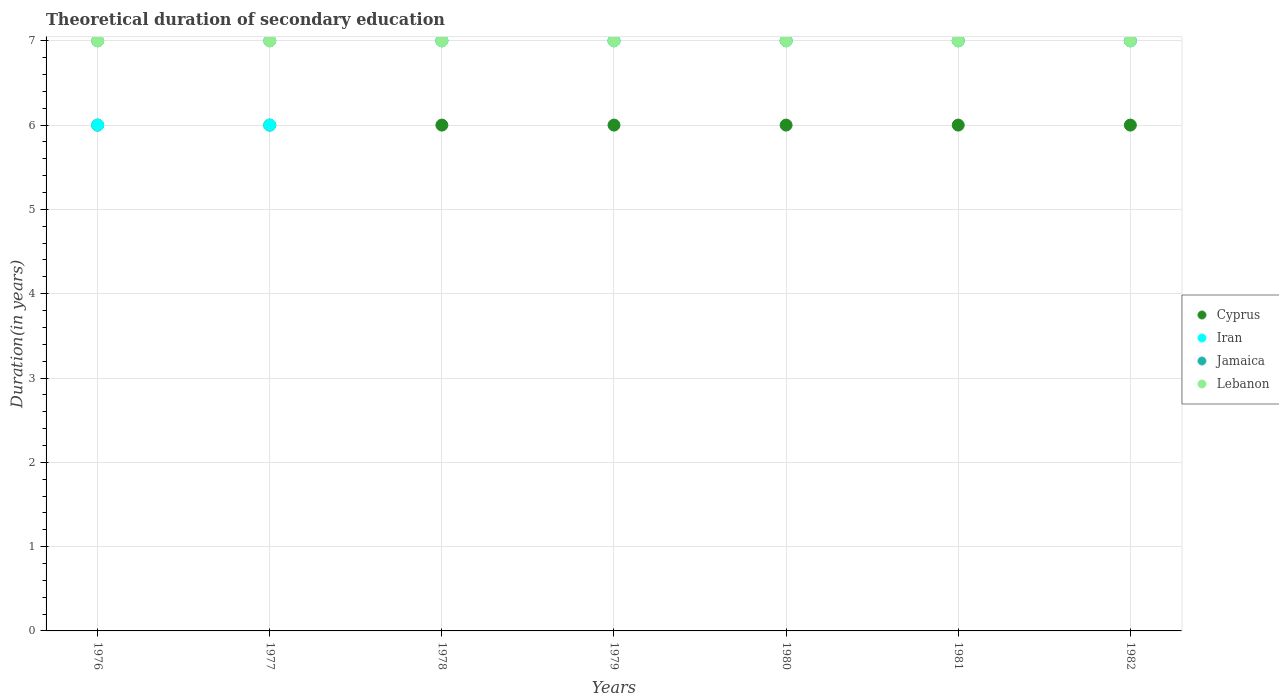How many different coloured dotlines are there?
Your answer should be very brief. 4. Is the number of dotlines equal to the number of legend labels?
Provide a short and direct response. Yes. What is the total theoretical duration of secondary education in Iran in 1978?
Offer a very short reply. 7. Across all years, what is the maximum total theoretical duration of secondary education in Cyprus?
Offer a very short reply. 6. Across all years, what is the minimum total theoretical duration of secondary education in Lebanon?
Your answer should be very brief. 7. In which year was the total theoretical duration of secondary education in Lebanon maximum?
Your response must be concise. 1976. In which year was the total theoretical duration of secondary education in Cyprus minimum?
Keep it short and to the point. 1976. What is the total total theoretical duration of secondary education in Cyprus in the graph?
Provide a succinct answer. 42. What is the difference between the total theoretical duration of secondary education in Jamaica in 1976 and that in 1981?
Your answer should be compact. 0. What is the difference between the total theoretical duration of secondary education in Iran in 1979 and the total theoretical duration of secondary education in Cyprus in 1978?
Offer a terse response. 1. What is the average total theoretical duration of secondary education in Iran per year?
Give a very brief answer. 6.71. In the year 1976, what is the difference between the total theoretical duration of secondary education in Lebanon and total theoretical duration of secondary education in Jamaica?
Provide a succinct answer. 0. In how many years, is the total theoretical duration of secondary education in Cyprus greater than 0.6000000000000001 years?
Provide a succinct answer. 7. What is the ratio of the total theoretical duration of secondary education in Jamaica in 1977 to that in 1978?
Offer a very short reply. 1. What is the difference between the highest and the lowest total theoretical duration of secondary education in Iran?
Your answer should be compact. 1. In how many years, is the total theoretical duration of secondary education in Cyprus greater than the average total theoretical duration of secondary education in Cyprus taken over all years?
Your answer should be compact. 0. Is the sum of the total theoretical duration of secondary education in Lebanon in 1976 and 1981 greater than the maximum total theoretical duration of secondary education in Cyprus across all years?
Your answer should be very brief. Yes. Is it the case that in every year, the sum of the total theoretical duration of secondary education in Lebanon and total theoretical duration of secondary education in Jamaica  is greater than the sum of total theoretical duration of secondary education in Cyprus and total theoretical duration of secondary education in Iran?
Your answer should be compact. No. Does the total theoretical duration of secondary education in Jamaica monotonically increase over the years?
Your answer should be very brief. No. How many dotlines are there?
Ensure brevity in your answer.  4. How many years are there in the graph?
Your answer should be compact. 7. Does the graph contain any zero values?
Offer a very short reply. No. Where does the legend appear in the graph?
Give a very brief answer. Center right. What is the title of the graph?
Make the answer very short. Theoretical duration of secondary education. What is the label or title of the X-axis?
Offer a very short reply. Years. What is the label or title of the Y-axis?
Offer a terse response. Duration(in years). What is the Duration(in years) of Iran in 1976?
Make the answer very short. 6. What is the Duration(in years) in Cyprus in 1977?
Your response must be concise. 6. What is the Duration(in years) in Iran in 1977?
Keep it short and to the point. 6. What is the Duration(in years) in Jamaica in 1977?
Offer a very short reply. 7. What is the Duration(in years) of Cyprus in 1978?
Make the answer very short. 6. What is the Duration(in years) in Iran in 1979?
Ensure brevity in your answer.  7. What is the Duration(in years) of Jamaica in 1979?
Provide a succinct answer. 7. What is the Duration(in years) in Cyprus in 1980?
Provide a succinct answer. 6. What is the Duration(in years) in Cyprus in 1981?
Your answer should be compact. 6. What is the Duration(in years) of Jamaica in 1981?
Make the answer very short. 7. What is the Duration(in years) in Iran in 1982?
Keep it short and to the point. 7. What is the Duration(in years) in Lebanon in 1982?
Your response must be concise. 7. Across all years, what is the maximum Duration(in years) of Cyprus?
Make the answer very short. 6. Across all years, what is the maximum Duration(in years) in Iran?
Keep it short and to the point. 7. Across all years, what is the maximum Duration(in years) of Jamaica?
Offer a terse response. 7. Across all years, what is the minimum Duration(in years) in Cyprus?
Provide a short and direct response. 6. Across all years, what is the minimum Duration(in years) in Jamaica?
Give a very brief answer. 7. What is the total Duration(in years) of Cyprus in the graph?
Offer a very short reply. 42. What is the difference between the Duration(in years) in Cyprus in 1976 and that in 1977?
Offer a terse response. 0. What is the difference between the Duration(in years) in Jamaica in 1976 and that in 1977?
Your response must be concise. 0. What is the difference between the Duration(in years) in Cyprus in 1976 and that in 1978?
Your answer should be very brief. 0. What is the difference between the Duration(in years) of Iran in 1976 and that in 1978?
Your answer should be very brief. -1. What is the difference between the Duration(in years) in Iran in 1976 and that in 1979?
Your answer should be compact. -1. What is the difference between the Duration(in years) of Iran in 1976 and that in 1980?
Offer a terse response. -1. What is the difference between the Duration(in years) in Jamaica in 1976 and that in 1980?
Give a very brief answer. 0. What is the difference between the Duration(in years) in Iran in 1976 and that in 1981?
Your response must be concise. -1. What is the difference between the Duration(in years) in Jamaica in 1976 and that in 1981?
Ensure brevity in your answer.  0. What is the difference between the Duration(in years) of Lebanon in 1976 and that in 1981?
Your response must be concise. 0. What is the difference between the Duration(in years) of Iran in 1976 and that in 1982?
Ensure brevity in your answer.  -1. What is the difference between the Duration(in years) in Lebanon in 1976 and that in 1982?
Your answer should be compact. 0. What is the difference between the Duration(in years) in Cyprus in 1977 and that in 1978?
Your answer should be compact. 0. What is the difference between the Duration(in years) in Lebanon in 1977 and that in 1978?
Keep it short and to the point. 0. What is the difference between the Duration(in years) of Cyprus in 1977 and that in 1979?
Offer a terse response. 0. What is the difference between the Duration(in years) in Iran in 1977 and that in 1979?
Your answer should be very brief. -1. What is the difference between the Duration(in years) in Cyprus in 1977 and that in 1980?
Ensure brevity in your answer.  0. What is the difference between the Duration(in years) in Iran in 1977 and that in 1980?
Provide a succinct answer. -1. What is the difference between the Duration(in years) in Jamaica in 1977 and that in 1980?
Provide a succinct answer. 0. What is the difference between the Duration(in years) in Cyprus in 1977 and that in 1981?
Give a very brief answer. 0. What is the difference between the Duration(in years) of Jamaica in 1977 and that in 1981?
Keep it short and to the point. 0. What is the difference between the Duration(in years) of Lebanon in 1977 and that in 1981?
Provide a short and direct response. 0. What is the difference between the Duration(in years) in Iran in 1978 and that in 1979?
Make the answer very short. 0. What is the difference between the Duration(in years) in Cyprus in 1978 and that in 1980?
Provide a short and direct response. 0. What is the difference between the Duration(in years) in Iran in 1978 and that in 1980?
Give a very brief answer. 0. What is the difference between the Duration(in years) of Jamaica in 1978 and that in 1980?
Make the answer very short. 0. What is the difference between the Duration(in years) in Jamaica in 1978 and that in 1981?
Keep it short and to the point. 0. What is the difference between the Duration(in years) in Cyprus in 1978 and that in 1982?
Give a very brief answer. 0. What is the difference between the Duration(in years) in Iran in 1978 and that in 1982?
Your answer should be compact. 0. What is the difference between the Duration(in years) in Cyprus in 1979 and that in 1980?
Provide a succinct answer. 0. What is the difference between the Duration(in years) in Iran in 1979 and that in 1980?
Keep it short and to the point. 0. What is the difference between the Duration(in years) in Lebanon in 1979 and that in 1980?
Offer a very short reply. 0. What is the difference between the Duration(in years) of Cyprus in 1979 and that in 1981?
Your response must be concise. 0. What is the difference between the Duration(in years) of Jamaica in 1979 and that in 1981?
Provide a short and direct response. 0. What is the difference between the Duration(in years) of Lebanon in 1979 and that in 1981?
Provide a short and direct response. 0. What is the difference between the Duration(in years) of Cyprus in 1979 and that in 1982?
Your response must be concise. 0. What is the difference between the Duration(in years) in Iran in 1979 and that in 1982?
Ensure brevity in your answer.  0. What is the difference between the Duration(in years) in Cyprus in 1980 and that in 1981?
Provide a succinct answer. 0. What is the difference between the Duration(in years) of Iran in 1980 and that in 1981?
Give a very brief answer. 0. What is the difference between the Duration(in years) in Cyprus in 1980 and that in 1982?
Your response must be concise. 0. What is the difference between the Duration(in years) in Iran in 1980 and that in 1982?
Your response must be concise. 0. What is the difference between the Duration(in years) of Lebanon in 1980 and that in 1982?
Your answer should be very brief. 0. What is the difference between the Duration(in years) of Cyprus in 1981 and that in 1982?
Provide a short and direct response. 0. What is the difference between the Duration(in years) in Iran in 1981 and that in 1982?
Your answer should be very brief. 0. What is the difference between the Duration(in years) in Iran in 1976 and the Duration(in years) in Jamaica in 1977?
Provide a short and direct response. -1. What is the difference between the Duration(in years) in Iran in 1976 and the Duration(in years) in Lebanon in 1977?
Keep it short and to the point. -1. What is the difference between the Duration(in years) in Jamaica in 1976 and the Duration(in years) in Lebanon in 1977?
Ensure brevity in your answer.  0. What is the difference between the Duration(in years) in Cyprus in 1976 and the Duration(in years) in Iran in 1978?
Provide a succinct answer. -1. What is the difference between the Duration(in years) in Cyprus in 1976 and the Duration(in years) in Jamaica in 1978?
Offer a very short reply. -1. What is the difference between the Duration(in years) of Iran in 1976 and the Duration(in years) of Lebanon in 1978?
Keep it short and to the point. -1. What is the difference between the Duration(in years) in Jamaica in 1976 and the Duration(in years) in Lebanon in 1978?
Your answer should be compact. 0. What is the difference between the Duration(in years) in Cyprus in 1976 and the Duration(in years) in Iran in 1979?
Offer a very short reply. -1. What is the difference between the Duration(in years) in Cyprus in 1976 and the Duration(in years) in Jamaica in 1979?
Your response must be concise. -1. What is the difference between the Duration(in years) in Cyprus in 1976 and the Duration(in years) in Lebanon in 1979?
Ensure brevity in your answer.  -1. What is the difference between the Duration(in years) of Iran in 1976 and the Duration(in years) of Lebanon in 1979?
Your response must be concise. -1. What is the difference between the Duration(in years) in Jamaica in 1976 and the Duration(in years) in Lebanon in 1979?
Ensure brevity in your answer.  0. What is the difference between the Duration(in years) of Cyprus in 1976 and the Duration(in years) of Jamaica in 1980?
Make the answer very short. -1. What is the difference between the Duration(in years) of Iran in 1976 and the Duration(in years) of Lebanon in 1980?
Provide a short and direct response. -1. What is the difference between the Duration(in years) in Jamaica in 1976 and the Duration(in years) in Lebanon in 1980?
Provide a short and direct response. 0. What is the difference between the Duration(in years) in Cyprus in 1976 and the Duration(in years) in Iran in 1981?
Offer a very short reply. -1. What is the difference between the Duration(in years) of Cyprus in 1976 and the Duration(in years) of Lebanon in 1981?
Give a very brief answer. -1. What is the difference between the Duration(in years) in Cyprus in 1976 and the Duration(in years) in Jamaica in 1982?
Make the answer very short. -1. What is the difference between the Duration(in years) of Cyprus in 1976 and the Duration(in years) of Lebanon in 1982?
Your answer should be very brief. -1. What is the difference between the Duration(in years) in Iran in 1976 and the Duration(in years) in Jamaica in 1982?
Offer a very short reply. -1. What is the difference between the Duration(in years) in Jamaica in 1976 and the Duration(in years) in Lebanon in 1982?
Offer a terse response. 0. What is the difference between the Duration(in years) in Cyprus in 1977 and the Duration(in years) in Jamaica in 1978?
Provide a succinct answer. -1. What is the difference between the Duration(in years) in Jamaica in 1977 and the Duration(in years) in Lebanon in 1978?
Give a very brief answer. 0. What is the difference between the Duration(in years) in Cyprus in 1977 and the Duration(in years) in Iran in 1979?
Your answer should be compact. -1. What is the difference between the Duration(in years) in Iran in 1977 and the Duration(in years) in Lebanon in 1979?
Your answer should be compact. -1. What is the difference between the Duration(in years) in Cyprus in 1977 and the Duration(in years) in Iran in 1980?
Give a very brief answer. -1. What is the difference between the Duration(in years) of Cyprus in 1977 and the Duration(in years) of Jamaica in 1980?
Your answer should be compact. -1. What is the difference between the Duration(in years) of Cyprus in 1977 and the Duration(in years) of Lebanon in 1980?
Keep it short and to the point. -1. What is the difference between the Duration(in years) in Iran in 1977 and the Duration(in years) in Jamaica in 1980?
Your answer should be compact. -1. What is the difference between the Duration(in years) in Iran in 1977 and the Duration(in years) in Lebanon in 1980?
Your answer should be very brief. -1. What is the difference between the Duration(in years) in Jamaica in 1977 and the Duration(in years) in Lebanon in 1980?
Your answer should be compact. 0. What is the difference between the Duration(in years) in Cyprus in 1977 and the Duration(in years) in Jamaica in 1981?
Offer a very short reply. -1. What is the difference between the Duration(in years) in Cyprus in 1977 and the Duration(in years) in Lebanon in 1981?
Make the answer very short. -1. What is the difference between the Duration(in years) in Iran in 1977 and the Duration(in years) in Jamaica in 1981?
Your answer should be very brief. -1. What is the difference between the Duration(in years) of Iran in 1977 and the Duration(in years) of Lebanon in 1981?
Provide a short and direct response. -1. What is the difference between the Duration(in years) in Cyprus in 1977 and the Duration(in years) in Lebanon in 1982?
Your response must be concise. -1. What is the difference between the Duration(in years) in Iran in 1977 and the Duration(in years) in Jamaica in 1982?
Provide a succinct answer. -1. What is the difference between the Duration(in years) in Iran in 1977 and the Duration(in years) in Lebanon in 1982?
Your answer should be very brief. -1. What is the difference between the Duration(in years) in Iran in 1978 and the Duration(in years) in Jamaica in 1979?
Make the answer very short. 0. What is the difference between the Duration(in years) in Cyprus in 1978 and the Duration(in years) in Lebanon in 1980?
Offer a very short reply. -1. What is the difference between the Duration(in years) of Iran in 1978 and the Duration(in years) of Lebanon in 1980?
Your answer should be very brief. 0. What is the difference between the Duration(in years) in Jamaica in 1978 and the Duration(in years) in Lebanon in 1980?
Provide a succinct answer. 0. What is the difference between the Duration(in years) in Cyprus in 1978 and the Duration(in years) in Iran in 1981?
Your answer should be very brief. -1. What is the difference between the Duration(in years) of Cyprus in 1978 and the Duration(in years) of Jamaica in 1981?
Offer a very short reply. -1. What is the difference between the Duration(in years) of Iran in 1978 and the Duration(in years) of Lebanon in 1981?
Offer a terse response. 0. What is the difference between the Duration(in years) of Jamaica in 1978 and the Duration(in years) of Lebanon in 1981?
Give a very brief answer. 0. What is the difference between the Duration(in years) in Cyprus in 1978 and the Duration(in years) in Jamaica in 1982?
Your answer should be very brief. -1. What is the difference between the Duration(in years) of Iran in 1978 and the Duration(in years) of Jamaica in 1982?
Keep it short and to the point. 0. What is the difference between the Duration(in years) in Iran in 1978 and the Duration(in years) in Lebanon in 1982?
Your answer should be compact. 0. What is the difference between the Duration(in years) of Iran in 1979 and the Duration(in years) of Jamaica in 1980?
Make the answer very short. 0. What is the difference between the Duration(in years) of Iran in 1979 and the Duration(in years) of Lebanon in 1980?
Your answer should be very brief. 0. What is the difference between the Duration(in years) in Cyprus in 1979 and the Duration(in years) in Jamaica in 1981?
Give a very brief answer. -1. What is the difference between the Duration(in years) of Cyprus in 1979 and the Duration(in years) of Iran in 1982?
Your answer should be compact. -1. What is the difference between the Duration(in years) in Iran in 1979 and the Duration(in years) in Lebanon in 1982?
Ensure brevity in your answer.  0. What is the difference between the Duration(in years) of Cyprus in 1980 and the Duration(in years) of Lebanon in 1981?
Offer a terse response. -1. What is the difference between the Duration(in years) of Iran in 1980 and the Duration(in years) of Jamaica in 1981?
Keep it short and to the point. 0. What is the difference between the Duration(in years) of Iran in 1980 and the Duration(in years) of Lebanon in 1981?
Provide a succinct answer. 0. What is the difference between the Duration(in years) of Jamaica in 1980 and the Duration(in years) of Lebanon in 1981?
Offer a terse response. 0. What is the difference between the Duration(in years) of Cyprus in 1980 and the Duration(in years) of Iran in 1982?
Keep it short and to the point. -1. What is the difference between the Duration(in years) of Cyprus in 1980 and the Duration(in years) of Jamaica in 1982?
Your response must be concise. -1. What is the difference between the Duration(in years) of Iran in 1980 and the Duration(in years) of Lebanon in 1982?
Offer a terse response. 0. What is the difference between the Duration(in years) in Jamaica in 1980 and the Duration(in years) in Lebanon in 1982?
Offer a very short reply. 0. What is the difference between the Duration(in years) in Cyprus in 1981 and the Duration(in years) in Iran in 1982?
Keep it short and to the point. -1. What is the difference between the Duration(in years) in Cyprus in 1981 and the Duration(in years) in Lebanon in 1982?
Provide a succinct answer. -1. What is the difference between the Duration(in years) in Jamaica in 1981 and the Duration(in years) in Lebanon in 1982?
Ensure brevity in your answer.  0. What is the average Duration(in years) of Cyprus per year?
Offer a terse response. 6. What is the average Duration(in years) of Iran per year?
Keep it short and to the point. 6.71. In the year 1976, what is the difference between the Duration(in years) of Cyprus and Duration(in years) of Iran?
Your answer should be very brief. 0. In the year 1976, what is the difference between the Duration(in years) in Cyprus and Duration(in years) in Lebanon?
Your answer should be very brief. -1. In the year 1976, what is the difference between the Duration(in years) in Iran and Duration(in years) in Jamaica?
Give a very brief answer. -1. In the year 1976, what is the difference between the Duration(in years) in Iran and Duration(in years) in Lebanon?
Your answer should be very brief. -1. In the year 1977, what is the difference between the Duration(in years) of Jamaica and Duration(in years) of Lebanon?
Offer a terse response. 0. In the year 1978, what is the difference between the Duration(in years) of Cyprus and Duration(in years) of Jamaica?
Ensure brevity in your answer.  -1. In the year 1978, what is the difference between the Duration(in years) of Iran and Duration(in years) of Jamaica?
Make the answer very short. 0. In the year 1979, what is the difference between the Duration(in years) in Cyprus and Duration(in years) in Iran?
Your answer should be very brief. -1. In the year 1980, what is the difference between the Duration(in years) in Cyprus and Duration(in years) in Iran?
Offer a terse response. -1. In the year 1980, what is the difference between the Duration(in years) in Cyprus and Duration(in years) in Jamaica?
Provide a succinct answer. -1. In the year 1980, what is the difference between the Duration(in years) in Iran and Duration(in years) in Jamaica?
Your answer should be compact. 0. In the year 1980, what is the difference between the Duration(in years) of Jamaica and Duration(in years) of Lebanon?
Provide a succinct answer. 0. In the year 1981, what is the difference between the Duration(in years) in Cyprus and Duration(in years) in Lebanon?
Your response must be concise. -1. In the year 1981, what is the difference between the Duration(in years) of Jamaica and Duration(in years) of Lebanon?
Offer a very short reply. 0. In the year 1982, what is the difference between the Duration(in years) of Cyprus and Duration(in years) of Iran?
Your answer should be compact. -1. In the year 1982, what is the difference between the Duration(in years) of Cyprus and Duration(in years) of Lebanon?
Offer a terse response. -1. In the year 1982, what is the difference between the Duration(in years) in Iran and Duration(in years) in Lebanon?
Offer a terse response. 0. In the year 1982, what is the difference between the Duration(in years) in Jamaica and Duration(in years) in Lebanon?
Offer a very short reply. 0. What is the ratio of the Duration(in years) in Cyprus in 1976 to that in 1977?
Your answer should be very brief. 1. What is the ratio of the Duration(in years) in Iran in 1976 to that in 1977?
Provide a succinct answer. 1. What is the ratio of the Duration(in years) of Lebanon in 1976 to that in 1978?
Your answer should be compact. 1. What is the ratio of the Duration(in years) of Iran in 1976 to that in 1979?
Your response must be concise. 0.86. What is the ratio of the Duration(in years) of Jamaica in 1976 to that in 1979?
Keep it short and to the point. 1. What is the ratio of the Duration(in years) in Lebanon in 1976 to that in 1979?
Your answer should be compact. 1. What is the ratio of the Duration(in years) of Cyprus in 1976 to that in 1980?
Give a very brief answer. 1. What is the ratio of the Duration(in years) in Jamaica in 1976 to that in 1980?
Offer a terse response. 1. What is the ratio of the Duration(in years) in Cyprus in 1976 to that in 1981?
Your response must be concise. 1. What is the ratio of the Duration(in years) in Jamaica in 1976 to that in 1981?
Make the answer very short. 1. What is the ratio of the Duration(in years) in Lebanon in 1976 to that in 1981?
Your response must be concise. 1. What is the ratio of the Duration(in years) in Cyprus in 1976 to that in 1982?
Provide a short and direct response. 1. What is the ratio of the Duration(in years) in Iran in 1976 to that in 1982?
Provide a succinct answer. 0.86. What is the ratio of the Duration(in years) in Jamaica in 1976 to that in 1982?
Your answer should be compact. 1. What is the ratio of the Duration(in years) in Lebanon in 1976 to that in 1982?
Offer a terse response. 1. What is the ratio of the Duration(in years) of Cyprus in 1977 to that in 1978?
Your answer should be very brief. 1. What is the ratio of the Duration(in years) of Iran in 1977 to that in 1978?
Your response must be concise. 0.86. What is the ratio of the Duration(in years) in Jamaica in 1977 to that in 1978?
Your answer should be very brief. 1. What is the ratio of the Duration(in years) in Lebanon in 1977 to that in 1978?
Your answer should be compact. 1. What is the ratio of the Duration(in years) of Iran in 1977 to that in 1979?
Make the answer very short. 0.86. What is the ratio of the Duration(in years) in Lebanon in 1977 to that in 1979?
Offer a very short reply. 1. What is the ratio of the Duration(in years) of Cyprus in 1977 to that in 1980?
Offer a very short reply. 1. What is the ratio of the Duration(in years) of Iran in 1977 to that in 1980?
Provide a succinct answer. 0.86. What is the ratio of the Duration(in years) in Jamaica in 1977 to that in 1980?
Keep it short and to the point. 1. What is the ratio of the Duration(in years) of Cyprus in 1977 to that in 1981?
Offer a very short reply. 1. What is the ratio of the Duration(in years) in Iran in 1977 to that in 1981?
Your answer should be very brief. 0.86. What is the ratio of the Duration(in years) in Jamaica in 1977 to that in 1981?
Your answer should be compact. 1. What is the ratio of the Duration(in years) of Cyprus in 1977 to that in 1982?
Your answer should be compact. 1. What is the ratio of the Duration(in years) in Lebanon in 1977 to that in 1982?
Keep it short and to the point. 1. What is the ratio of the Duration(in years) in Iran in 1978 to that in 1979?
Offer a very short reply. 1. What is the ratio of the Duration(in years) of Cyprus in 1978 to that in 1980?
Your answer should be compact. 1. What is the ratio of the Duration(in years) of Cyprus in 1978 to that in 1981?
Ensure brevity in your answer.  1. What is the ratio of the Duration(in years) of Iran in 1978 to that in 1981?
Ensure brevity in your answer.  1. What is the ratio of the Duration(in years) of Jamaica in 1978 to that in 1981?
Make the answer very short. 1. What is the ratio of the Duration(in years) in Cyprus in 1978 to that in 1982?
Provide a short and direct response. 1. What is the ratio of the Duration(in years) of Cyprus in 1979 to that in 1980?
Your answer should be very brief. 1. What is the ratio of the Duration(in years) in Iran in 1979 to that in 1980?
Provide a short and direct response. 1. What is the ratio of the Duration(in years) in Jamaica in 1979 to that in 1980?
Ensure brevity in your answer.  1. What is the ratio of the Duration(in years) in Cyprus in 1979 to that in 1981?
Make the answer very short. 1. What is the ratio of the Duration(in years) in Iran in 1979 to that in 1981?
Offer a very short reply. 1. What is the ratio of the Duration(in years) in Jamaica in 1979 to that in 1981?
Keep it short and to the point. 1. What is the ratio of the Duration(in years) in Jamaica in 1979 to that in 1982?
Offer a terse response. 1. What is the ratio of the Duration(in years) in Cyprus in 1980 to that in 1981?
Give a very brief answer. 1. What is the ratio of the Duration(in years) of Jamaica in 1980 to that in 1981?
Provide a short and direct response. 1. What is the ratio of the Duration(in years) in Lebanon in 1980 to that in 1981?
Your answer should be very brief. 1. What is the ratio of the Duration(in years) of Cyprus in 1981 to that in 1982?
Your answer should be compact. 1. What is the ratio of the Duration(in years) of Iran in 1981 to that in 1982?
Provide a short and direct response. 1. What is the ratio of the Duration(in years) in Jamaica in 1981 to that in 1982?
Keep it short and to the point. 1. What is the difference between the highest and the second highest Duration(in years) in Jamaica?
Your answer should be very brief. 0. What is the difference between the highest and the lowest Duration(in years) in Cyprus?
Ensure brevity in your answer.  0. What is the difference between the highest and the lowest Duration(in years) in Jamaica?
Ensure brevity in your answer.  0. What is the difference between the highest and the lowest Duration(in years) of Lebanon?
Ensure brevity in your answer.  0. 